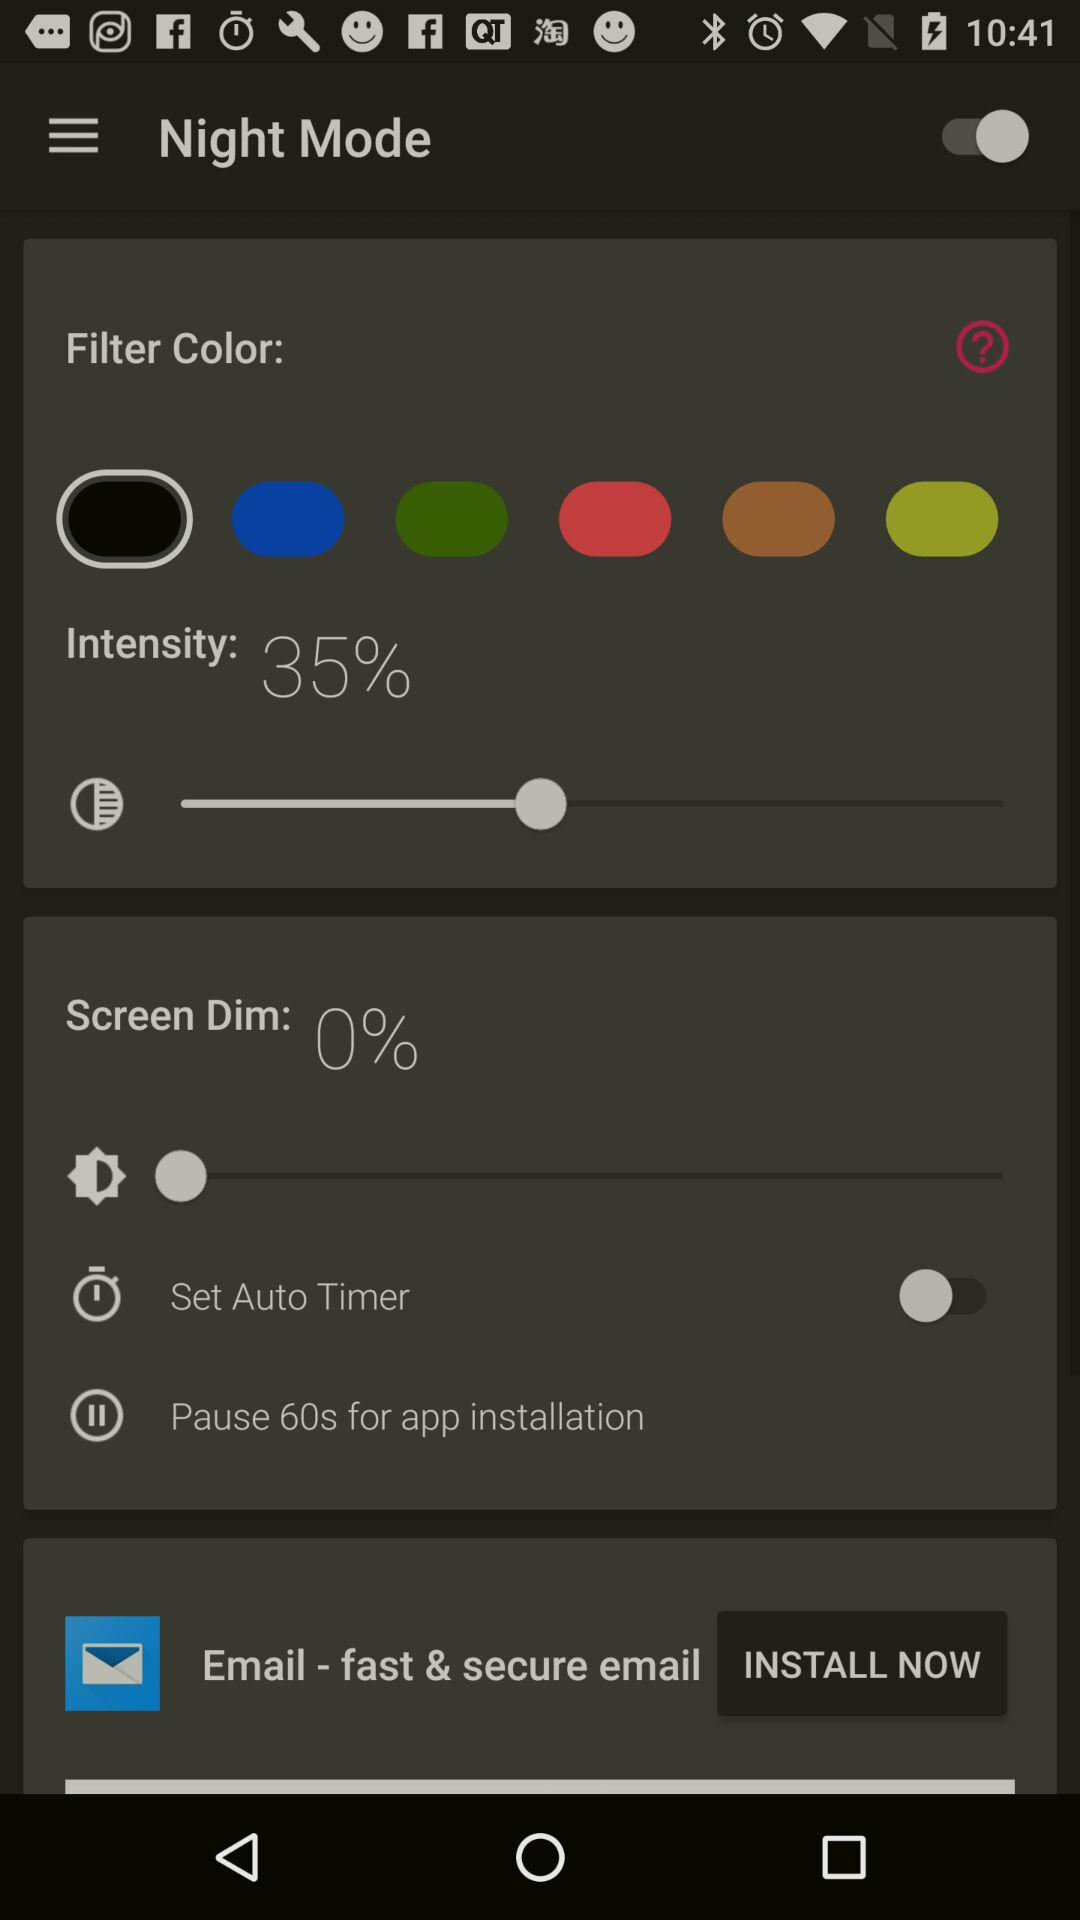What is the pause duration for app installation? The pause duration is 60 seconds. 